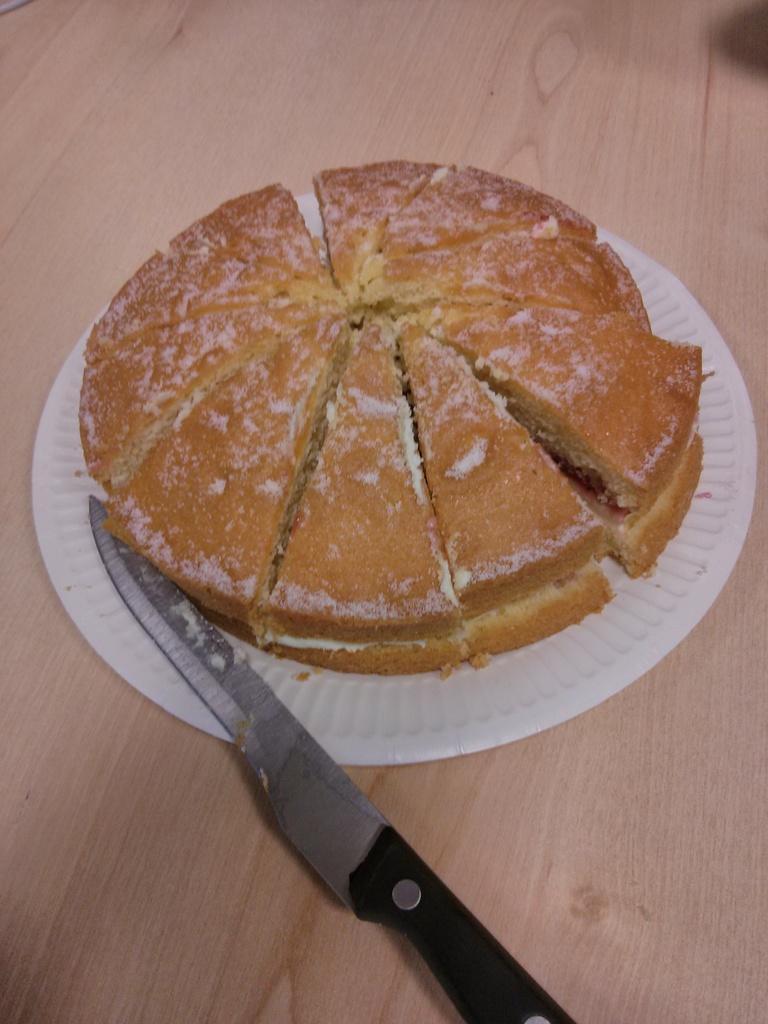How would you summarize this image in a sentence or two? This image consist of food which is on the plate and there is a knife which is on the surface which is brown in colour. 